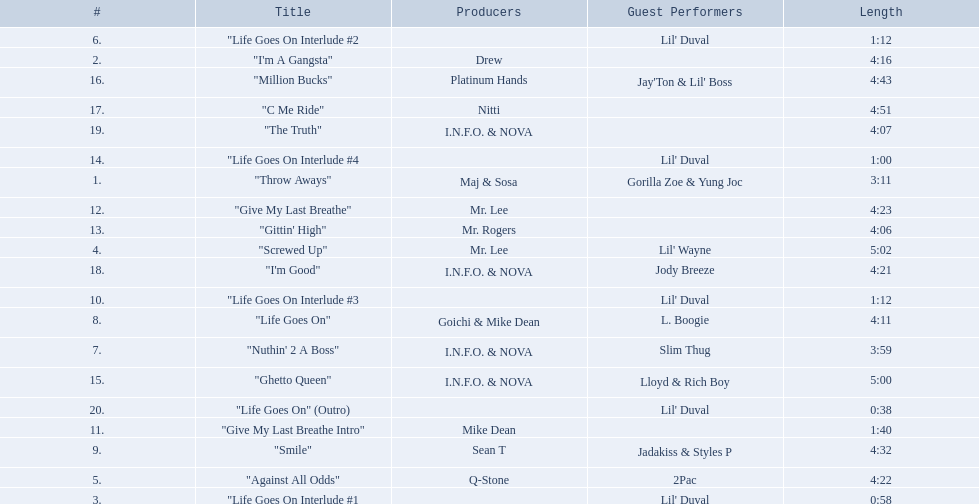What are the song lengths of all the songs on the album? 3:11, 4:16, 0:58, 5:02, 4:22, 1:12, 3:59, 4:11, 4:32, 1:12, 1:40, 4:23, 4:06, 1:00, 5:00, 4:43, 4:51, 4:21, 4:07, 0:38. Which is the longest of these? 5:02. 